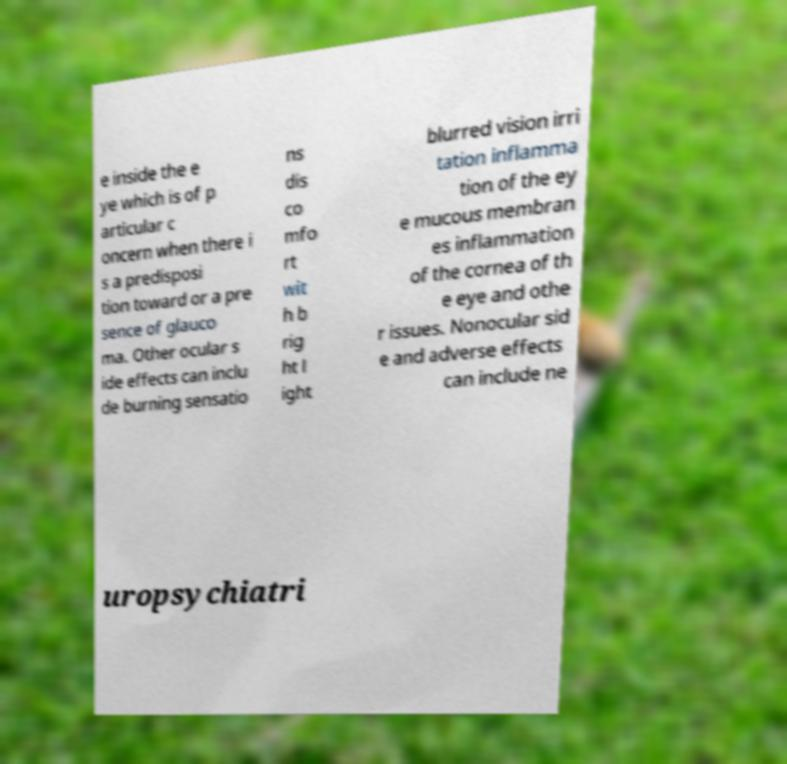Can you read and provide the text displayed in the image?This photo seems to have some interesting text. Can you extract and type it out for me? e inside the e ye which is of p articular c oncern when there i s a predisposi tion toward or a pre sence of glauco ma. Other ocular s ide effects can inclu de burning sensatio ns dis co mfo rt wit h b rig ht l ight blurred vision irri tation inflamma tion of the ey e mucous membran es inflammation of the cornea of th e eye and othe r issues. Nonocular sid e and adverse effects can include ne uropsychiatri 